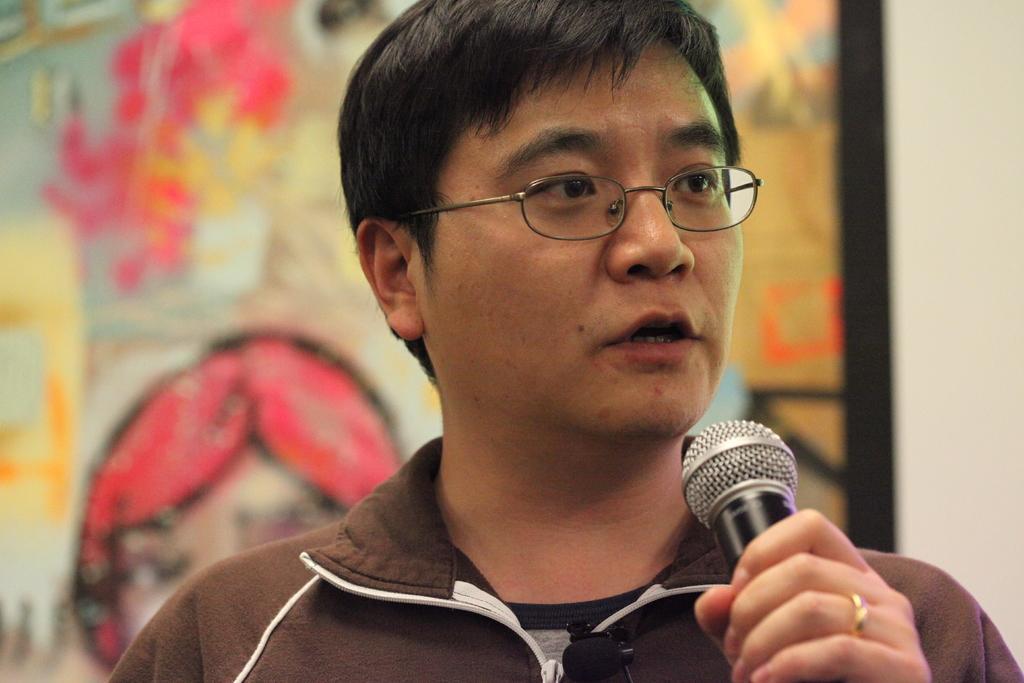In one or two sentences, can you explain what this image depicts? In this image I can see a man is holding a mic and also I can see he is wearing s specs. 